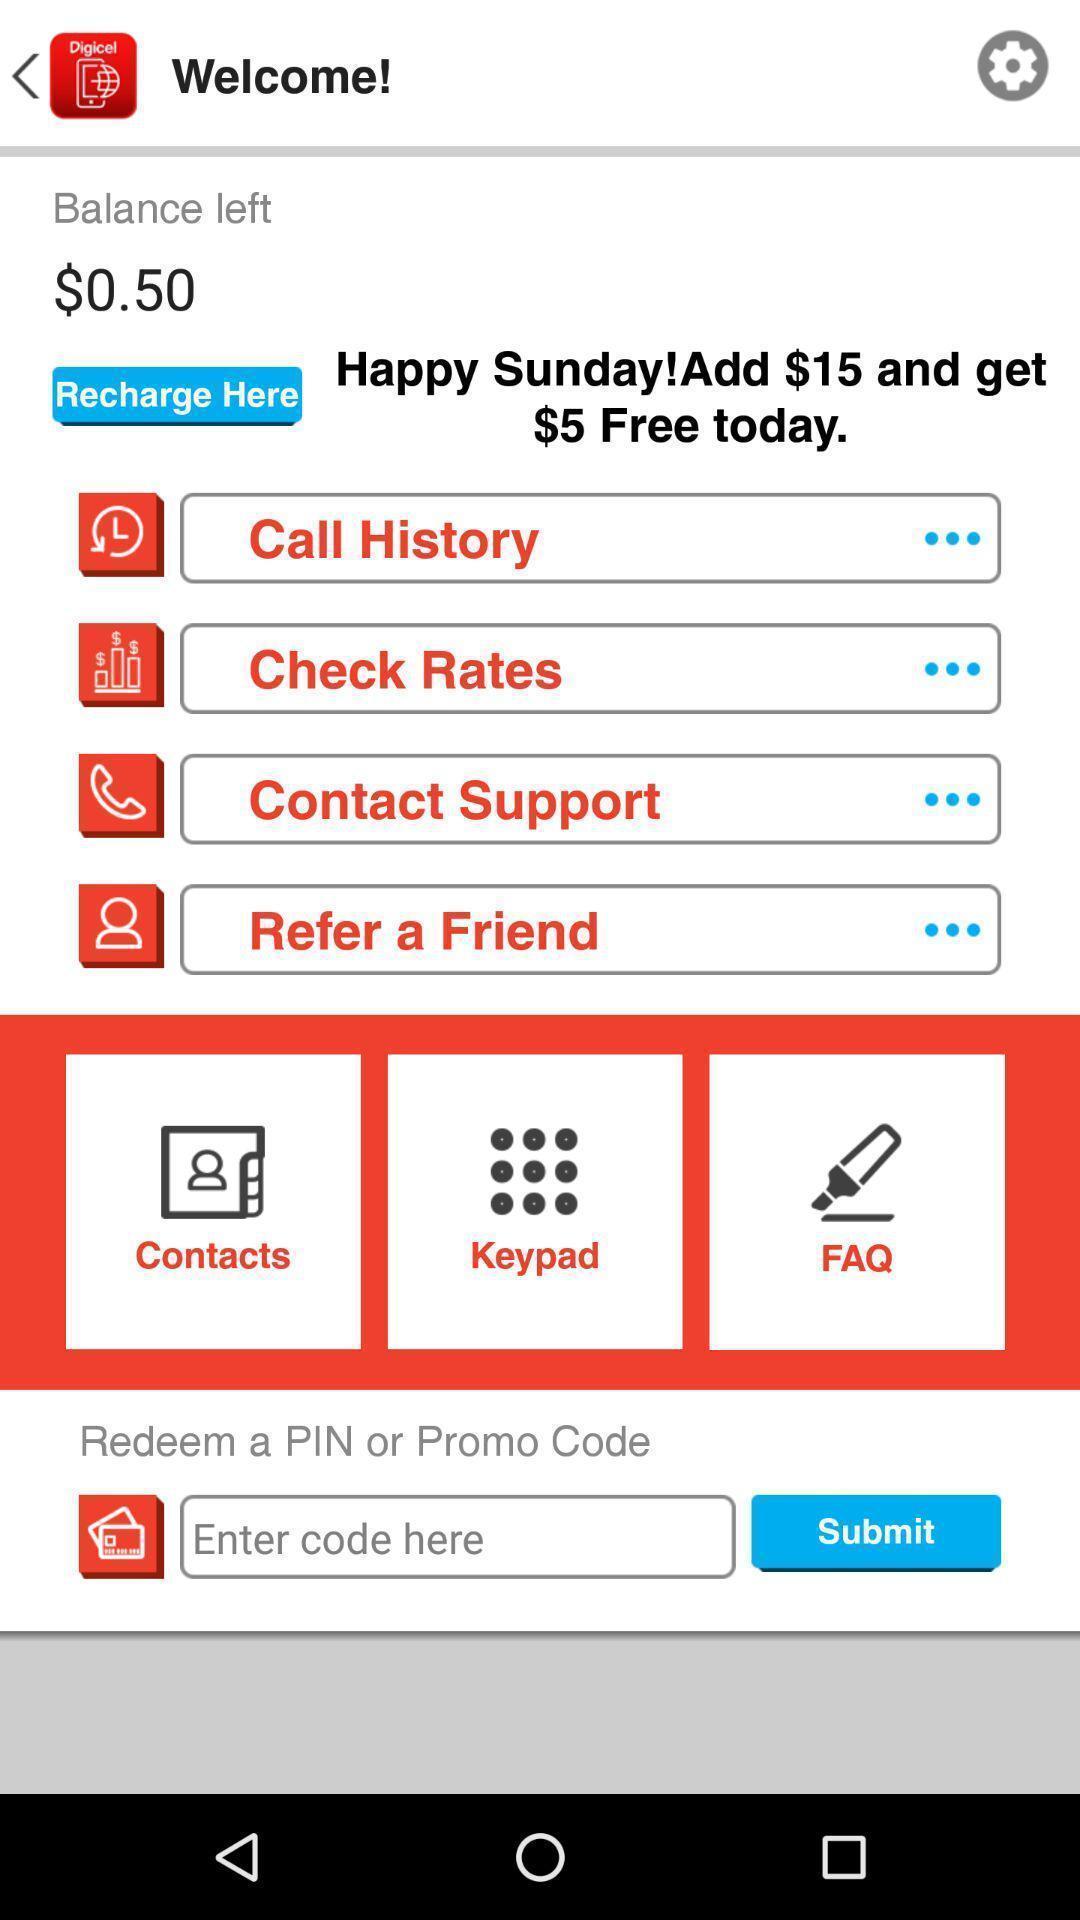Give me a summary of this screen capture. Welcome page for a recharge app. 